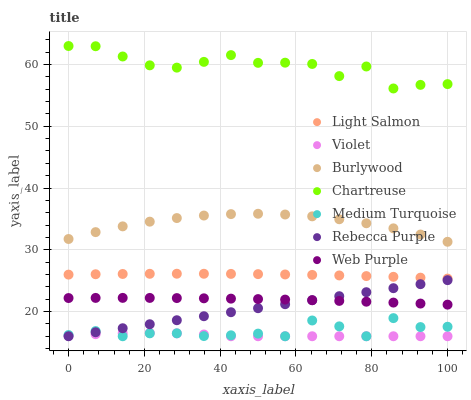Does Violet have the minimum area under the curve?
Answer yes or no. Yes. Does Chartreuse have the maximum area under the curve?
Answer yes or no. Yes. Does Burlywood have the minimum area under the curve?
Answer yes or no. No. Does Burlywood have the maximum area under the curve?
Answer yes or no. No. Is Rebecca Purple the smoothest?
Answer yes or no. Yes. Is Chartreuse the roughest?
Answer yes or no. Yes. Is Burlywood the smoothest?
Answer yes or no. No. Is Burlywood the roughest?
Answer yes or no. No. Does Rebecca Purple have the lowest value?
Answer yes or no. Yes. Does Burlywood have the lowest value?
Answer yes or no. No. Does Chartreuse have the highest value?
Answer yes or no. Yes. Does Burlywood have the highest value?
Answer yes or no. No. Is Rebecca Purple less than Burlywood?
Answer yes or no. Yes. Is Chartreuse greater than Rebecca Purple?
Answer yes or no. Yes. Does Medium Turquoise intersect Violet?
Answer yes or no. Yes. Is Medium Turquoise less than Violet?
Answer yes or no. No. Is Medium Turquoise greater than Violet?
Answer yes or no. No. Does Rebecca Purple intersect Burlywood?
Answer yes or no. No. 